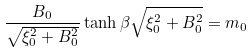Convert formula to latex. <formula><loc_0><loc_0><loc_500><loc_500>\frac { B _ { 0 } } { \sqrt { \xi _ { 0 } ^ { 2 } + B _ { 0 } ^ { 2 } } } \tanh \beta \sqrt { \xi _ { 0 } ^ { 2 } + B _ { 0 } ^ { 2 } } = m _ { 0 } \</formula> 